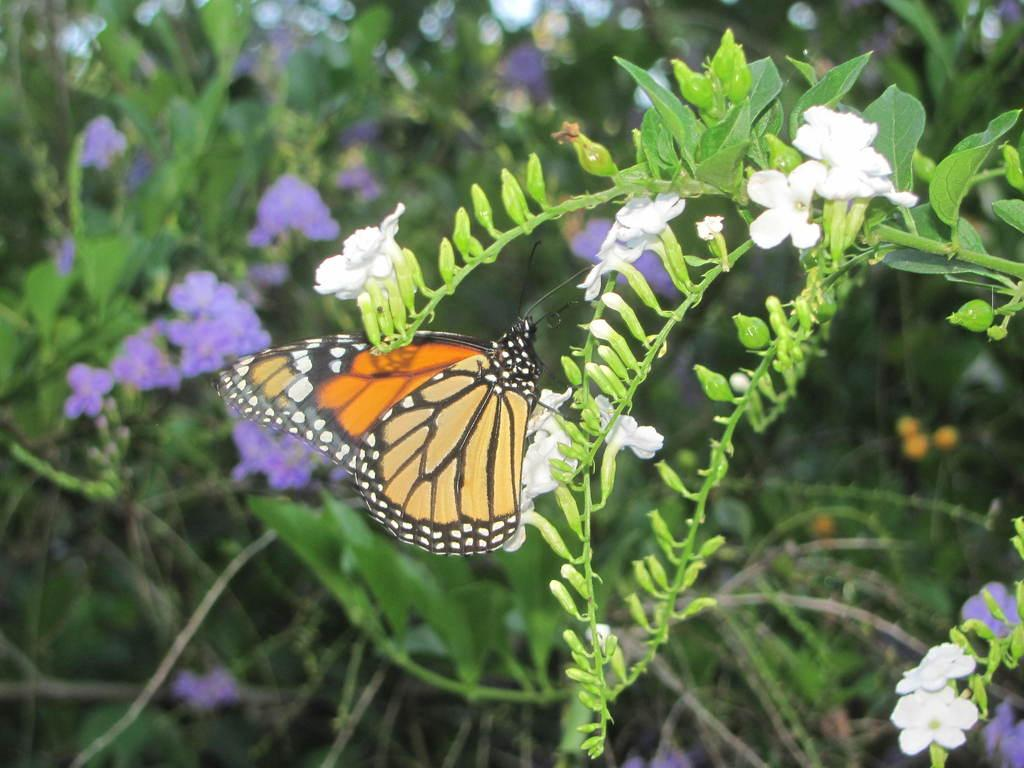What type of plant is present in the image? There is a plant with white flowers in the image. Are there any animals visible in the image? Yes, there is a butterfly in the image. What can be seen in the background of the image? In the background, there are plants with purple flowers. How many yaks are present in the image? There are no yaks present in the image. Can you describe the bone structure of the butterfly in the image? There is no mention of a bone structure in the image, as butterflies have an exoskeleton rather than a bone structure. 